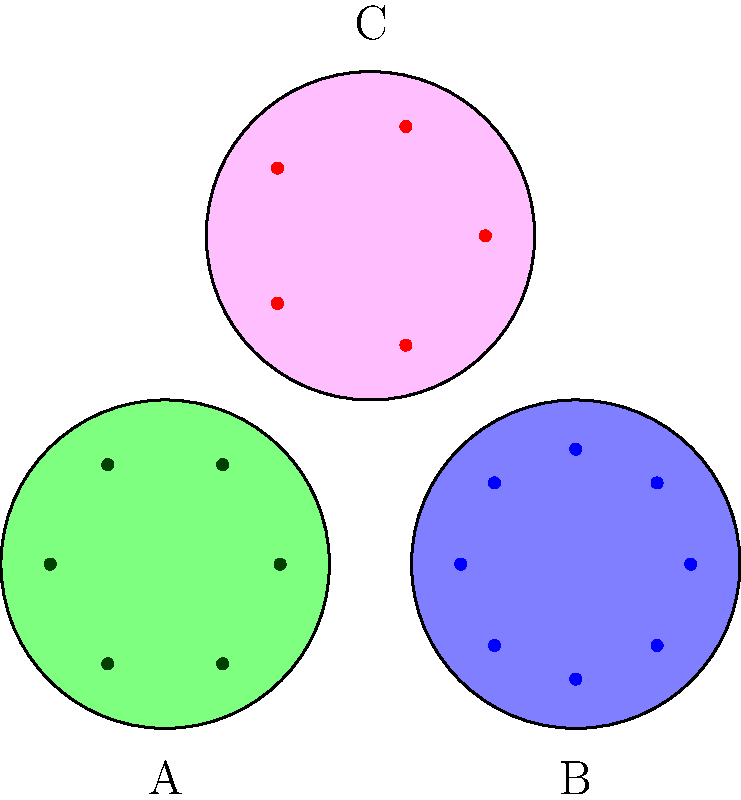Based on the image recognition of cultural artifacts from different ethnicities, which artifact is most likely associated with traditional Mesoamerican cultures? To answer this question, we need to analyze the characteristics of each artifact and compare them to known patterns in Mesoamerican cultural artifacts:

1. Artifact A (green):
   - Circular shape with 6 equally spaced dots
   - Green color, which could represent jade, a material highly valued in Mesoamerican cultures

2. Artifact B (blue):
   - Circular shape with 8 equally spaced dots
   - Blue color, which is less common in traditional Mesoamerican artifacts

3. Artifact C (pink):
   - Circular shape with 5 equally spaced dots
   - Pink/red color, which could represent the use of red pigments common in Mesoamerican art

Step-by-step analysis:
1. Mesoamerican cultures often used circular designs in their artifacts, so all three could potentially fit.
2. The number of dots or points in designs often had symbolic meaning:
   - The number 5 was significant in Mesoamerican cosmology, representing the four cardinal directions plus the center.
   - 6 and 8 were less commonly used in symbolic representations.
3. Colors:
   - Green (jade) was highly prized and used extensively in Mesoamerican cultures.
   - Red was also commonly used in Mesoamerican art and rituals.
   - Blue, while sometimes used, was less prominent in traditional Mesoamerican artifacts.

4. Considering these factors, Artifact A (green with 6 dots) and Artifact C (pink/red with 5 dots) are the strongest candidates.
5. However, the combination of the green color (representing jade) and the circular shape makes Artifact A the most likely to be associated with traditional Mesoamerican cultures.

Therefore, based on the image recognition and cultural context, Artifact A is the most likely to be associated with traditional Mesoamerican cultures.
Answer: Artifact A 